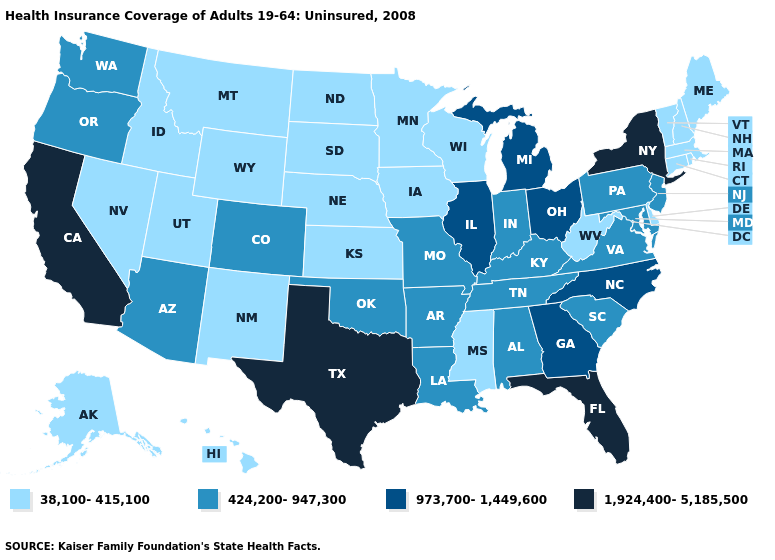Name the states that have a value in the range 424,200-947,300?
Write a very short answer. Alabama, Arizona, Arkansas, Colorado, Indiana, Kentucky, Louisiana, Maryland, Missouri, New Jersey, Oklahoma, Oregon, Pennsylvania, South Carolina, Tennessee, Virginia, Washington. Among the states that border Arkansas , which have the lowest value?
Short answer required. Mississippi. Which states have the highest value in the USA?
Quick response, please. California, Florida, New York, Texas. Does the map have missing data?
Keep it brief. No. Name the states that have a value in the range 1,924,400-5,185,500?
Answer briefly. California, Florida, New York, Texas. Name the states that have a value in the range 424,200-947,300?
Quick response, please. Alabama, Arizona, Arkansas, Colorado, Indiana, Kentucky, Louisiana, Maryland, Missouri, New Jersey, Oklahoma, Oregon, Pennsylvania, South Carolina, Tennessee, Virginia, Washington. Which states have the lowest value in the South?
Answer briefly. Delaware, Mississippi, West Virginia. Does Arizona have a higher value than Montana?
Keep it brief. Yes. Among the states that border Maryland , which have the highest value?
Write a very short answer. Pennsylvania, Virginia. Does West Virginia have a lower value than Oklahoma?
Give a very brief answer. Yes. What is the value of Alabama?
Give a very brief answer. 424,200-947,300. Does the first symbol in the legend represent the smallest category?
Keep it brief. Yes. Does Alaska have the lowest value in the USA?
Quick response, please. Yes. Does Vermont have a lower value than West Virginia?
Give a very brief answer. No. Which states hav the highest value in the MidWest?
Keep it brief. Illinois, Michigan, Ohio. 